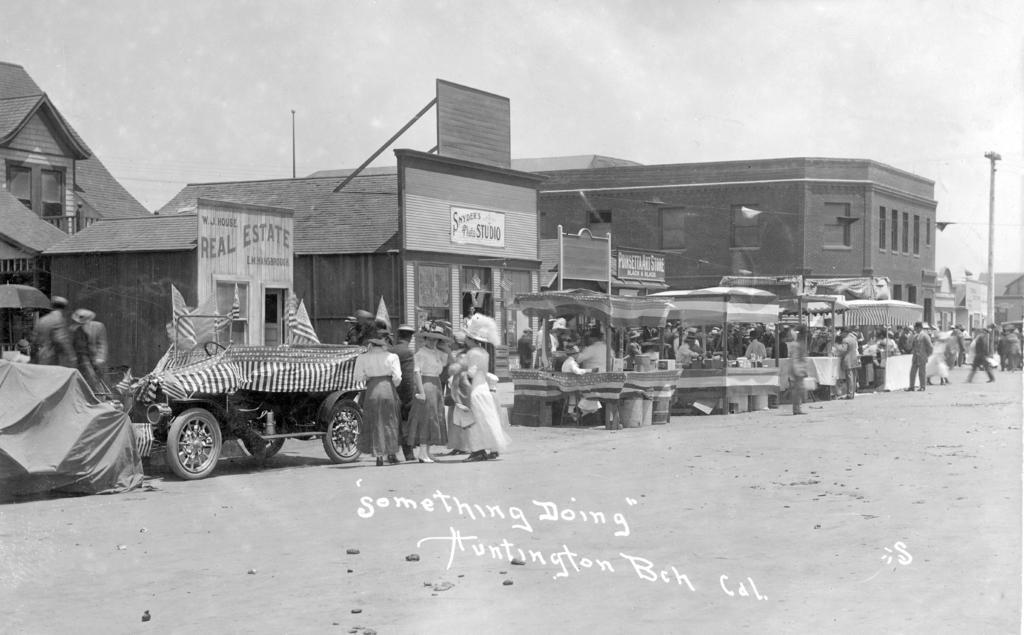Please provide a concise description of this image. In this picture we can see group of persons standing near to the tent. On the right there is a pole. Here we can see some boards which is on the wall. On the left there is a car which is near to the real estate board. On the top we can see sky and clouds. On the bottom there is a watermark. 